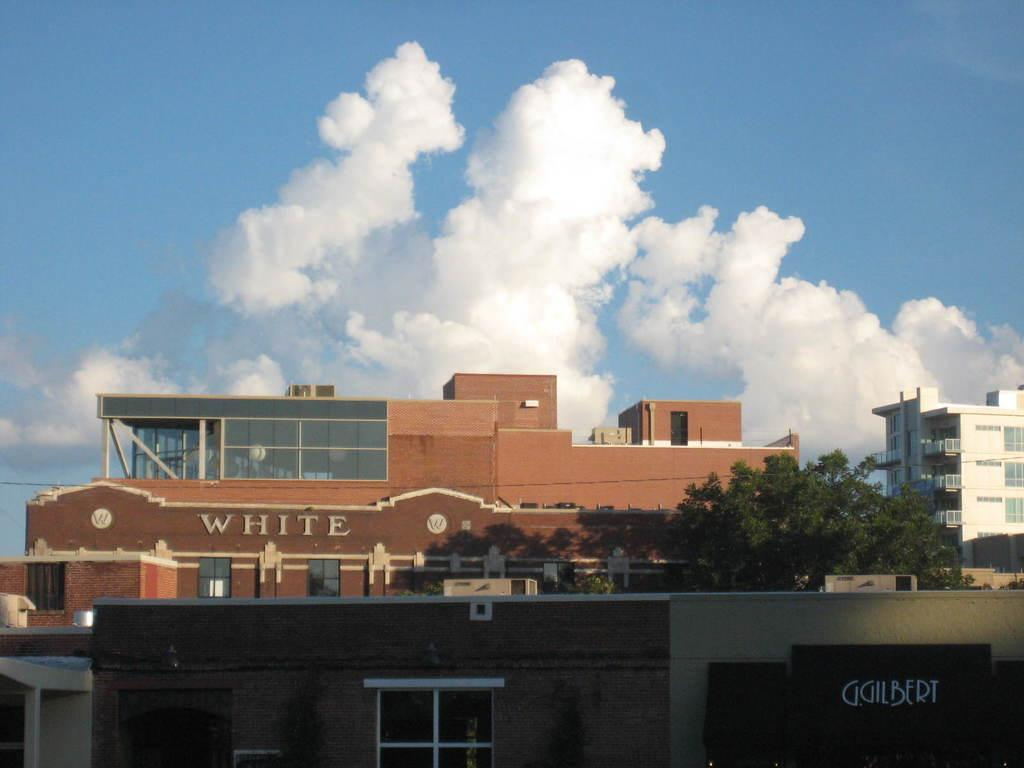What type of structures are present in the image? There are buildings in the image. Are there any natural elements in the image? Yes, there is a tree in the image. What is written on the buildings? There is text written on the buildings. Can the text be seen in the image? Yes, the text is visible in the image. How would you describe the weather in the image? The sky is cloudy in the image. What type of locket is hanging from the tree in the image? There is no locket present in the image; it features buildings, a tree, and text. How does the team interact with the cloud in the image? There is no team present in the image, and the cloud is a natural weather phenomenon, not an object that can be interacted with. 